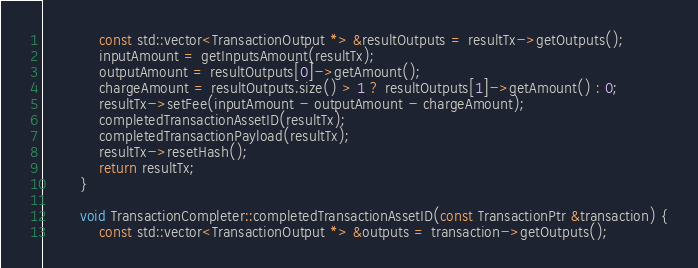<code> <loc_0><loc_0><loc_500><loc_500><_C++_>
			const std::vector<TransactionOutput *> &resultOutputs = resultTx->getOutputs();
			inputAmount = getInputsAmount(resultTx);
			outputAmount = resultOutputs[0]->getAmount();
			chargeAmount = resultOutputs.size() > 1 ? resultOutputs[1]->getAmount() : 0;
			resultTx->setFee(inputAmount - outputAmount - chargeAmount);
			completedTransactionAssetID(resultTx);
			completedTransactionPayload(resultTx);
			resultTx->resetHash();
			return resultTx;
		}

		void TransactionCompleter::completedTransactionAssetID(const TransactionPtr &transaction) {
			const std::vector<TransactionOutput *> &outputs = transaction->getOutputs();</code> 